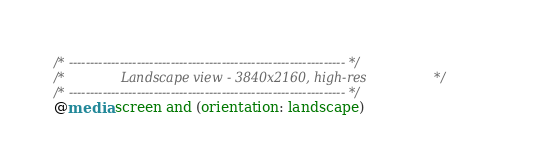<code> <loc_0><loc_0><loc_500><loc_500><_CSS_>/* ----------------------------------------------------------------- */
/*              Landscape view - 3840x2160, high-res                 */
/* ----------------------------------------------------------------- */
@media screen and (orientation: landscape) </code> 